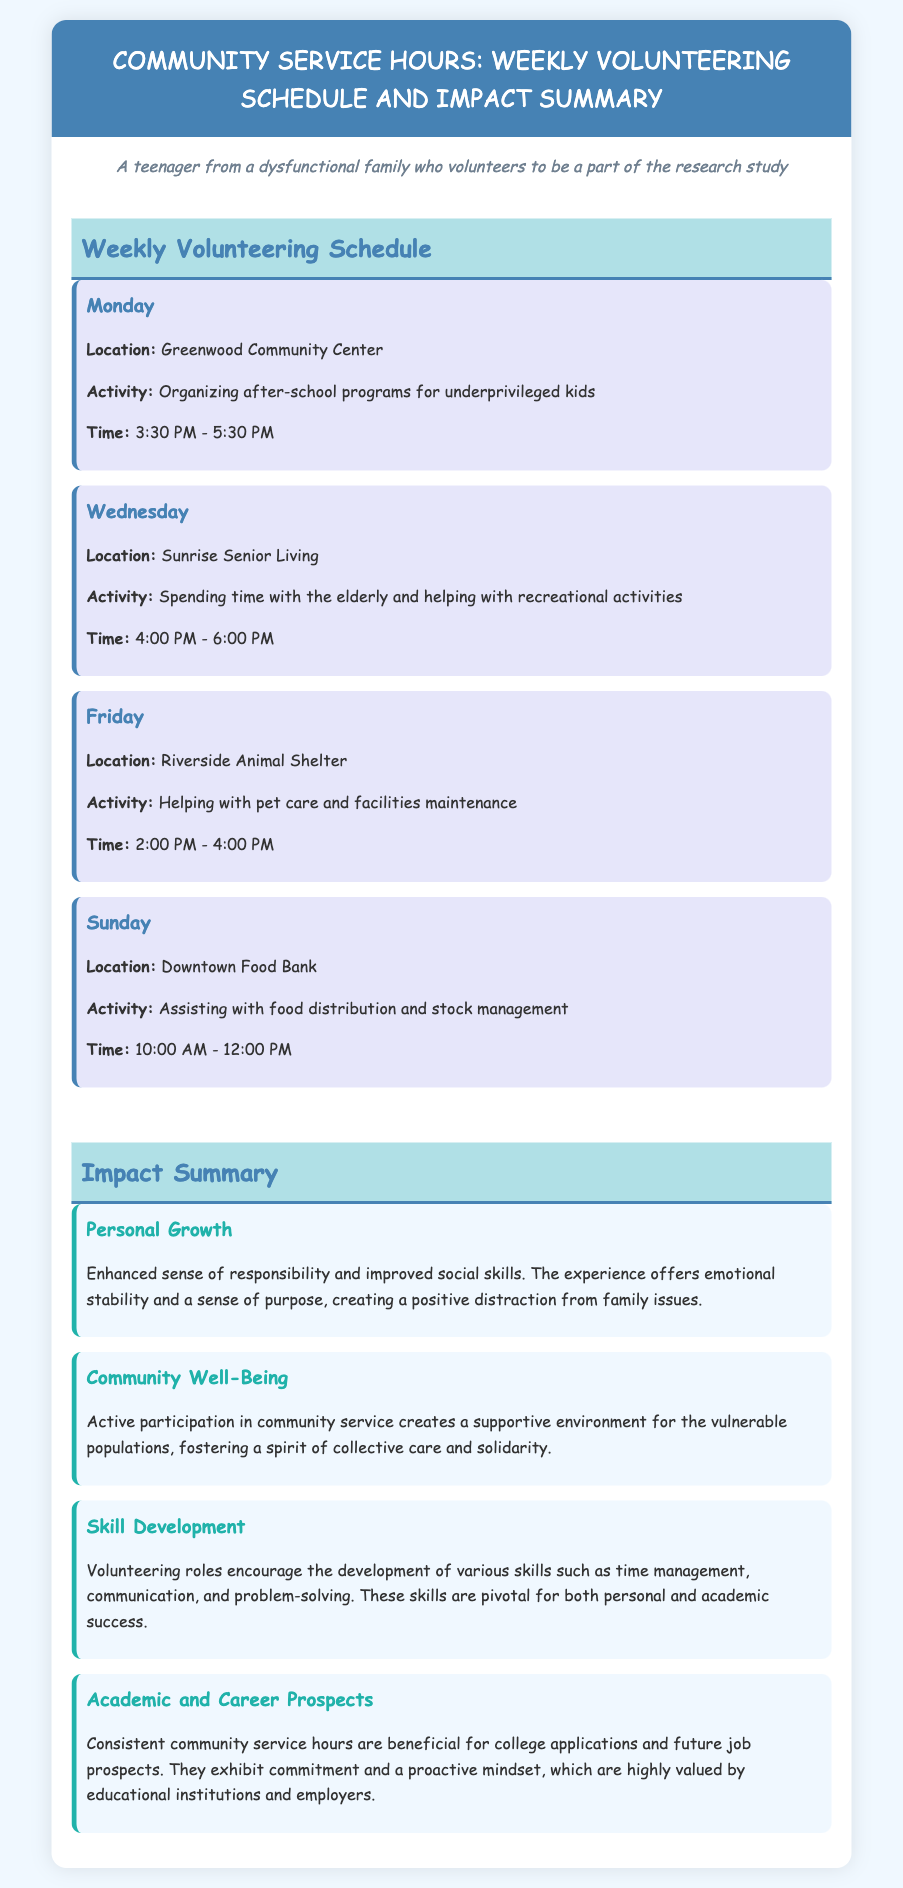What day is the volunteering activity at Greenwood Community Center? The volunteering activity at Greenwood Community Center takes place on Monday, as stated in the schedule.
Answer: Monday What time does the volunteering at Riverside Animal Shelter start? The volunteering at Riverside Animal Shelter starts at 2:00 PM, according to the schedule.
Answer: 2:00 PM Which activity is scheduled for Friday? The activity scheduled for Friday is helping with pet care and facilities maintenance at Riverside Animal Shelter.
Answer: Helping with pet care and facilities maintenance What is one benefit of volunteering mentioned in the Personal Growth impact area? The benefit of volunteering mentioned is an enhanced sense of responsibility, as noted in the Personal Growth impact summary.
Answer: Enhanced sense of responsibility How many hours of volunteering are conducted on Sunday? The document states that the volunteering hours on Sunday at the Downtown Food Bank are from 10:00 AM to 12:00 PM, which is 2 hours.
Answer: 2 hours What location is associated with spending time with the elderly? The location associated with spending time with the elderly is Sunrise Senior Living.
Answer: Sunrise Senior Living What is a skill developed through volunteering according to the document? The document lists time management as one of the skills developed through volunteering.
Answer: Time management How many days per week is volunteering scheduled? The volunteering schedule spans four days a week as outlined in the document.
Answer: Four days 